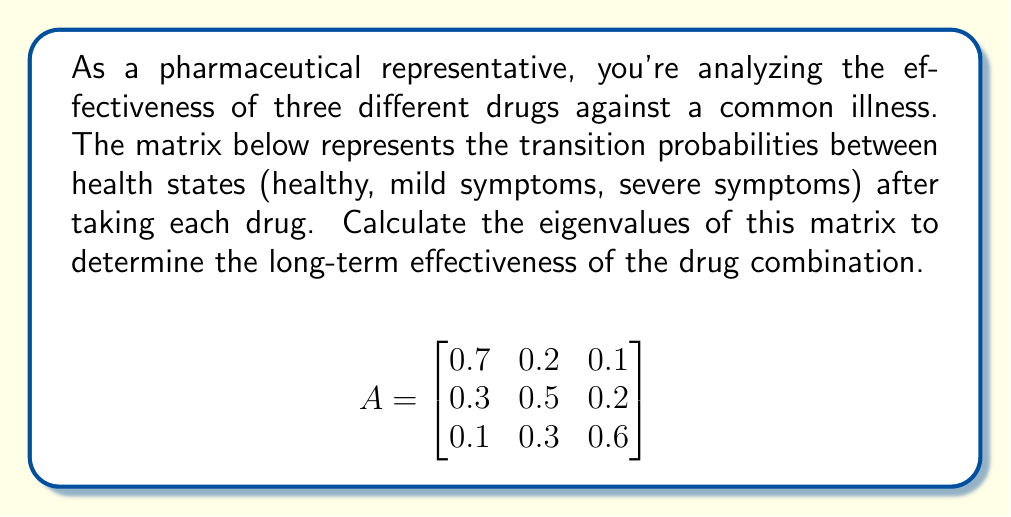Show me your answer to this math problem. To find the eigenvalues of matrix A, we need to solve the characteristic equation:

$$det(A - \lambda I) = 0$$

Where $I$ is the 3x3 identity matrix and $\lambda$ represents the eigenvalues.

Step 1: Set up the characteristic equation:
$$det\begin{pmatrix}
0.7-\lambda & 0.2 & 0.1 \\
0.3 & 0.5-\lambda & 0.2 \\
0.1 & 0.3 & 0.6-\lambda
\end{pmatrix} = 0$$

Step 2: Expand the determinant:
$$(0.7-\lambda)[(0.5-\lambda)(0.6-\lambda)-0.06] - 0.2[0.3(0.6-\lambda)-0.02] + 0.1[0.3(0.5-\lambda)-0.06] = 0$$

Step 3: Simplify:
$$\lambda^3 - 1.8\lambda^2 + 0.94\lambda - 0.14 = 0$$

Step 4: Solve the cubic equation. This can be done using the cubic formula or numerical methods. The solutions are the eigenvalues:

$\lambda_1 \approx 1$
$\lambda_2 \approx 0.5$
$\lambda_3 \approx 0.3$

These eigenvalues represent the long-term probabilities of being in each health state after repeated applications of the drug combination.
Answer: $\lambda_1 \approx 1$, $\lambda_2 \approx 0.5$, $\lambda_3 \approx 0.3$ 